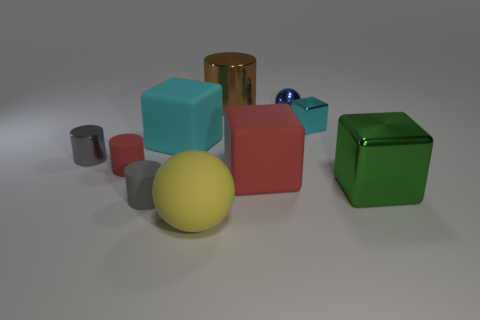There is a small object that is both in front of the tiny gray metallic cylinder and left of the tiny gray matte thing; what is its material?
Provide a short and direct response. Rubber. There is a small block; is it the same color as the matte block that is behind the small red cylinder?
Ensure brevity in your answer.  Yes. What material is the big cube that is the same color as the small cube?
Give a very brief answer. Rubber. What number of things have the same color as the small cube?
Give a very brief answer. 1. There is a small object that is made of the same material as the small red cylinder; what color is it?
Keep it short and to the point. Gray. What size is the ball that is in front of the big green object?
Provide a short and direct response. Large. There is a sphere behind the yellow thing; is its size the same as the big red matte thing?
Give a very brief answer. No. What is the material of the large yellow ball in front of the small metallic block?
Your response must be concise. Rubber. Is the number of small cyan metallic cubes greater than the number of large gray matte cylinders?
Ensure brevity in your answer.  Yes. What number of objects are gray rubber cylinders that are behind the yellow object or matte cylinders?
Offer a terse response. 2. 